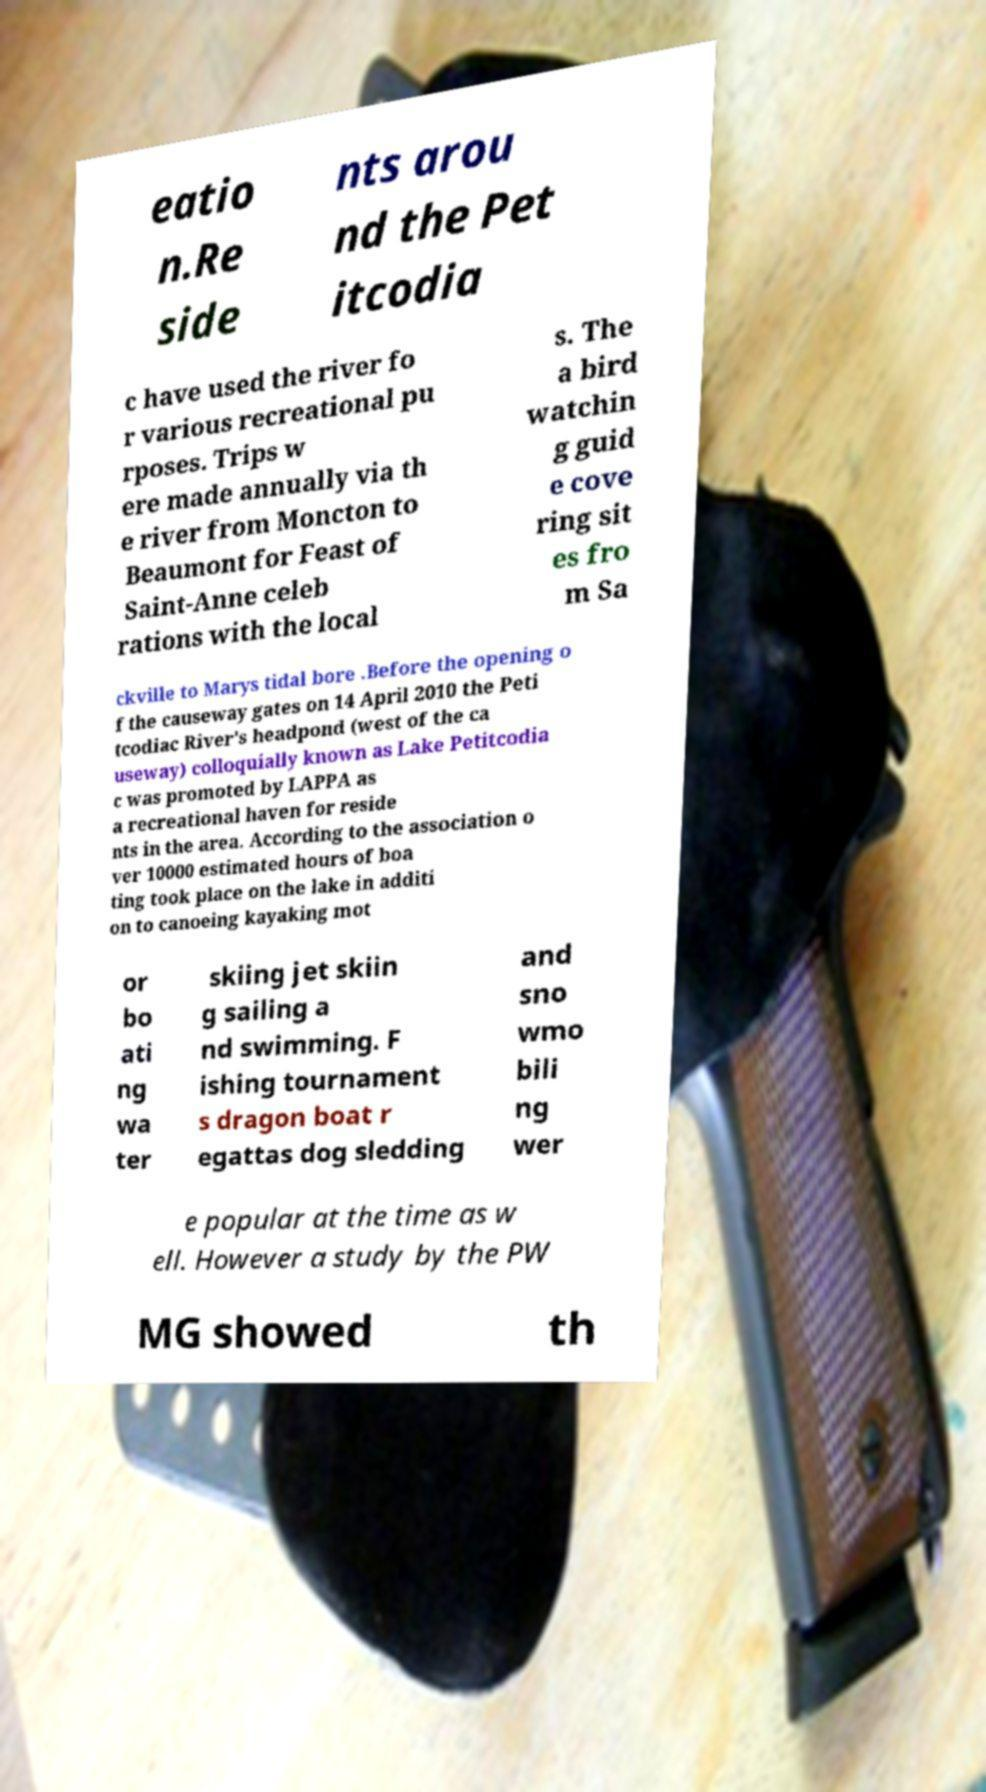Can you accurately transcribe the text from the provided image for me? eatio n.Re side nts arou nd the Pet itcodia c have used the river fo r various recreational pu rposes. Trips w ere made annually via th e river from Moncton to Beaumont for Feast of Saint-Anne celeb rations with the local s. The a bird watchin g guid e cove ring sit es fro m Sa ckville to Marys tidal bore .Before the opening o f the causeway gates on 14 April 2010 the Peti tcodiac River's headpond (west of the ca useway) colloquially known as Lake Petitcodia c was promoted by LAPPA as a recreational haven for reside nts in the area. According to the association o ver 10000 estimated hours of boa ting took place on the lake in additi on to canoeing kayaking mot or bo ati ng wa ter skiing jet skiin g sailing a nd swimming. F ishing tournament s dragon boat r egattas dog sledding and sno wmo bili ng wer e popular at the time as w ell. However a study by the PW MG showed th 